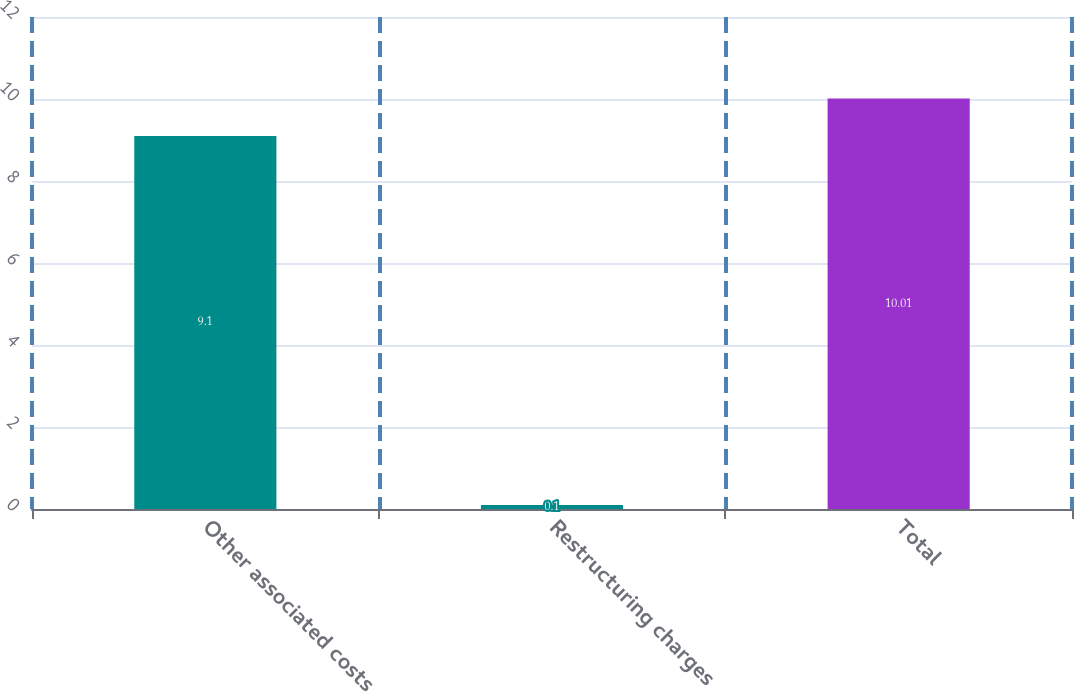Convert chart to OTSL. <chart><loc_0><loc_0><loc_500><loc_500><bar_chart><fcel>Other associated costs<fcel>Restructuring charges<fcel>Total<nl><fcel>9.1<fcel>0.1<fcel>10.01<nl></chart> 